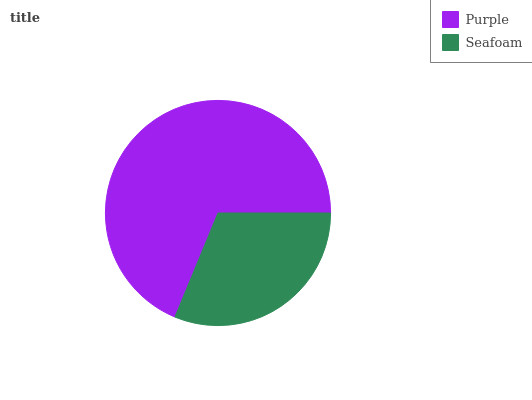Is Seafoam the minimum?
Answer yes or no. Yes. Is Purple the maximum?
Answer yes or no. Yes. Is Seafoam the maximum?
Answer yes or no. No. Is Purple greater than Seafoam?
Answer yes or no. Yes. Is Seafoam less than Purple?
Answer yes or no. Yes. Is Seafoam greater than Purple?
Answer yes or no. No. Is Purple less than Seafoam?
Answer yes or no. No. Is Purple the high median?
Answer yes or no. Yes. Is Seafoam the low median?
Answer yes or no. Yes. Is Seafoam the high median?
Answer yes or no. No. Is Purple the low median?
Answer yes or no. No. 